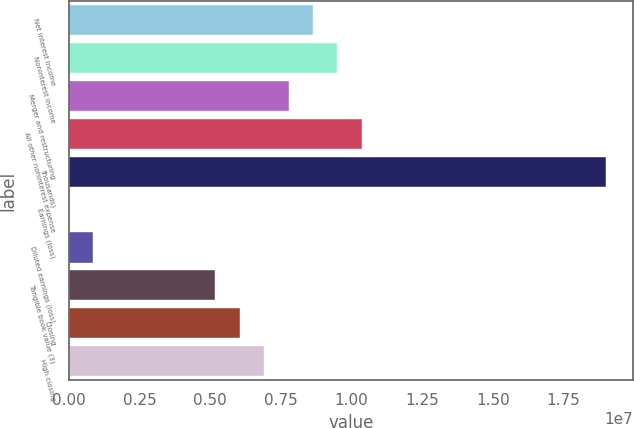Convert chart. <chart><loc_0><loc_0><loc_500><loc_500><bar_chart><fcel>Net interest income<fcel>Noninterest income<fcel>Merger and restructuring<fcel>All other noninterest expense<fcel>thousands)<fcel>Earnings (loss)<fcel>Diluted earnings (loss)<fcel>Tangible book value (3)<fcel>Closing<fcel>High closing<nl><fcel>8.63383e+06<fcel>9.49722e+06<fcel>7.77045e+06<fcel>1.03606e+07<fcel>1.89944e+07<fcel>0.26<fcel>863384<fcel>5.1803e+06<fcel>6.04368e+06<fcel>6.90707e+06<nl></chart> 